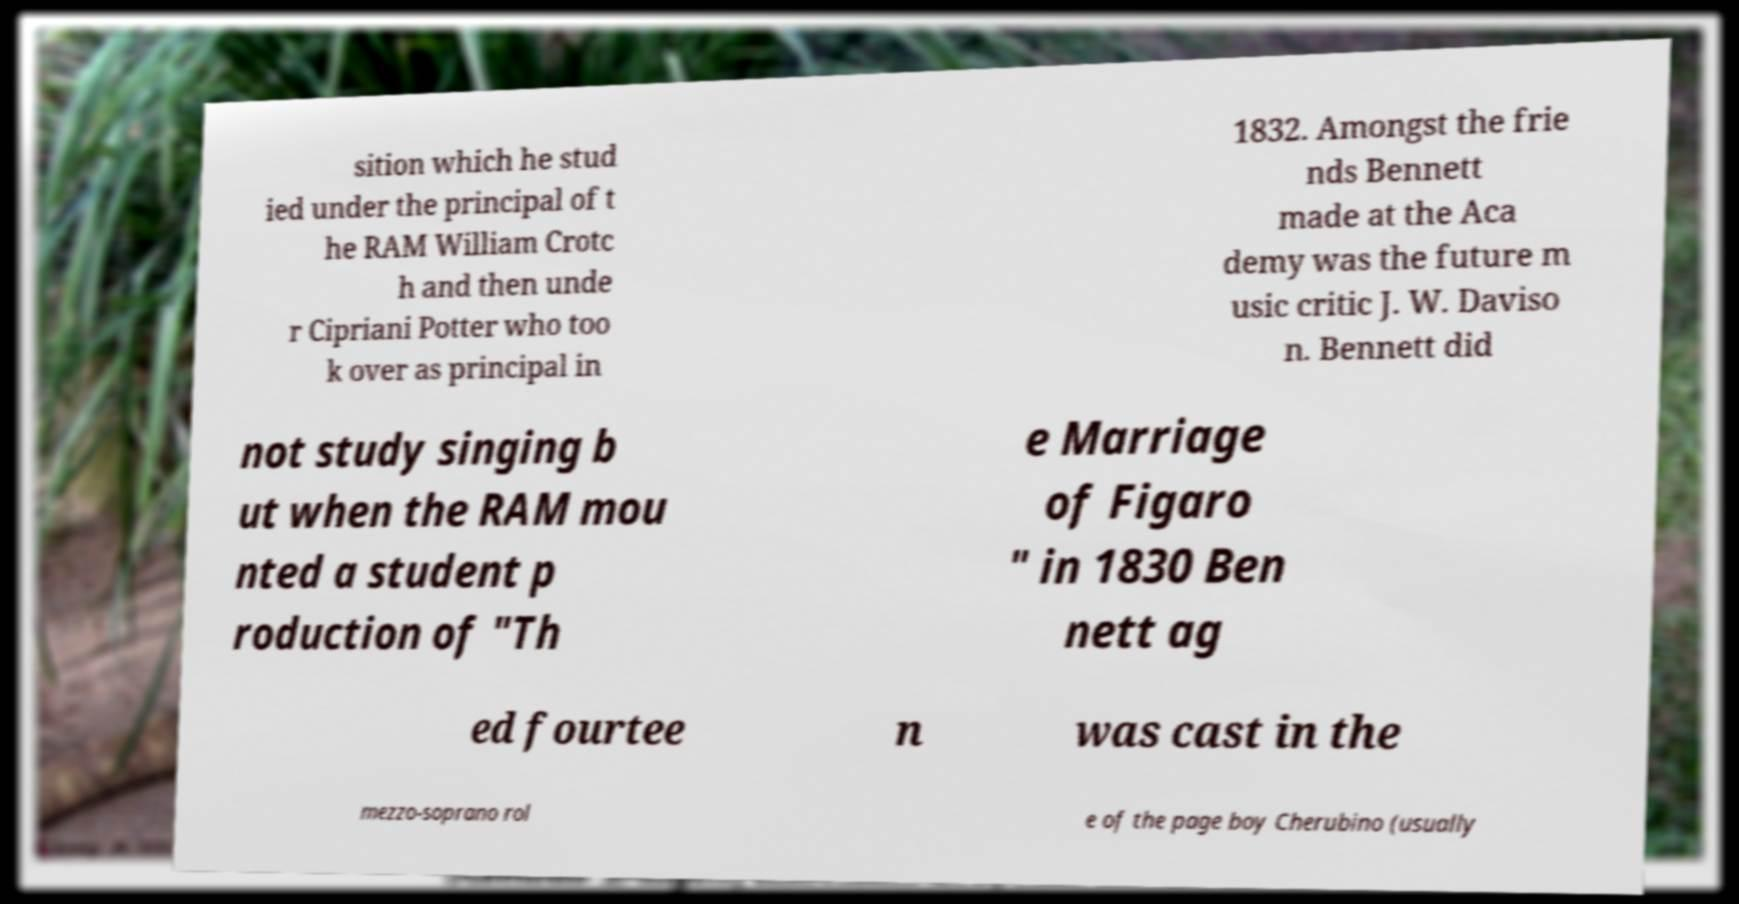Could you assist in decoding the text presented in this image and type it out clearly? sition which he stud ied under the principal of t he RAM William Crotc h and then unde r Cipriani Potter who too k over as principal in 1832. Amongst the frie nds Bennett made at the Aca demy was the future m usic critic J. W. Daviso n. Bennett did not study singing b ut when the RAM mou nted a student p roduction of "Th e Marriage of Figaro " in 1830 Ben nett ag ed fourtee n was cast in the mezzo-soprano rol e of the page boy Cherubino (usually 